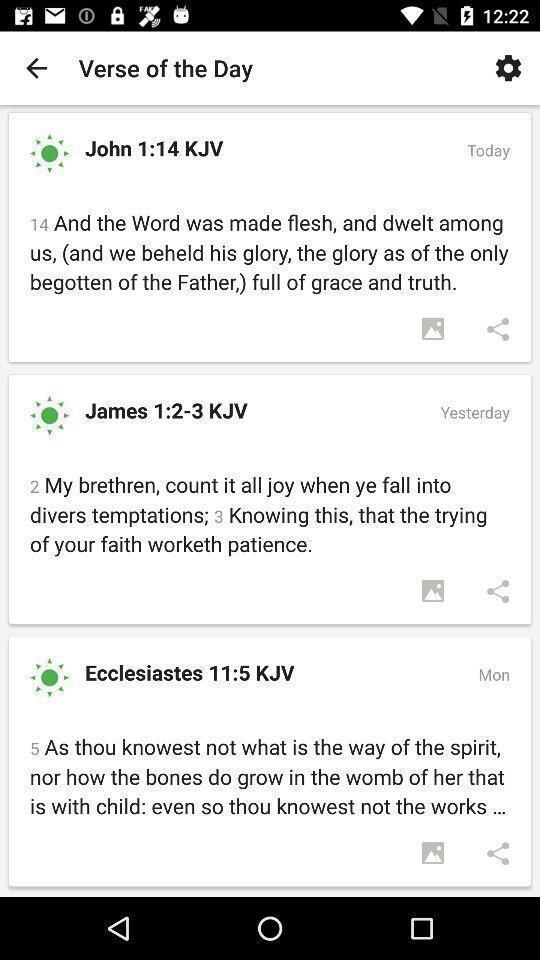Give me a summary of this screen capture. Page showing verses in app. 